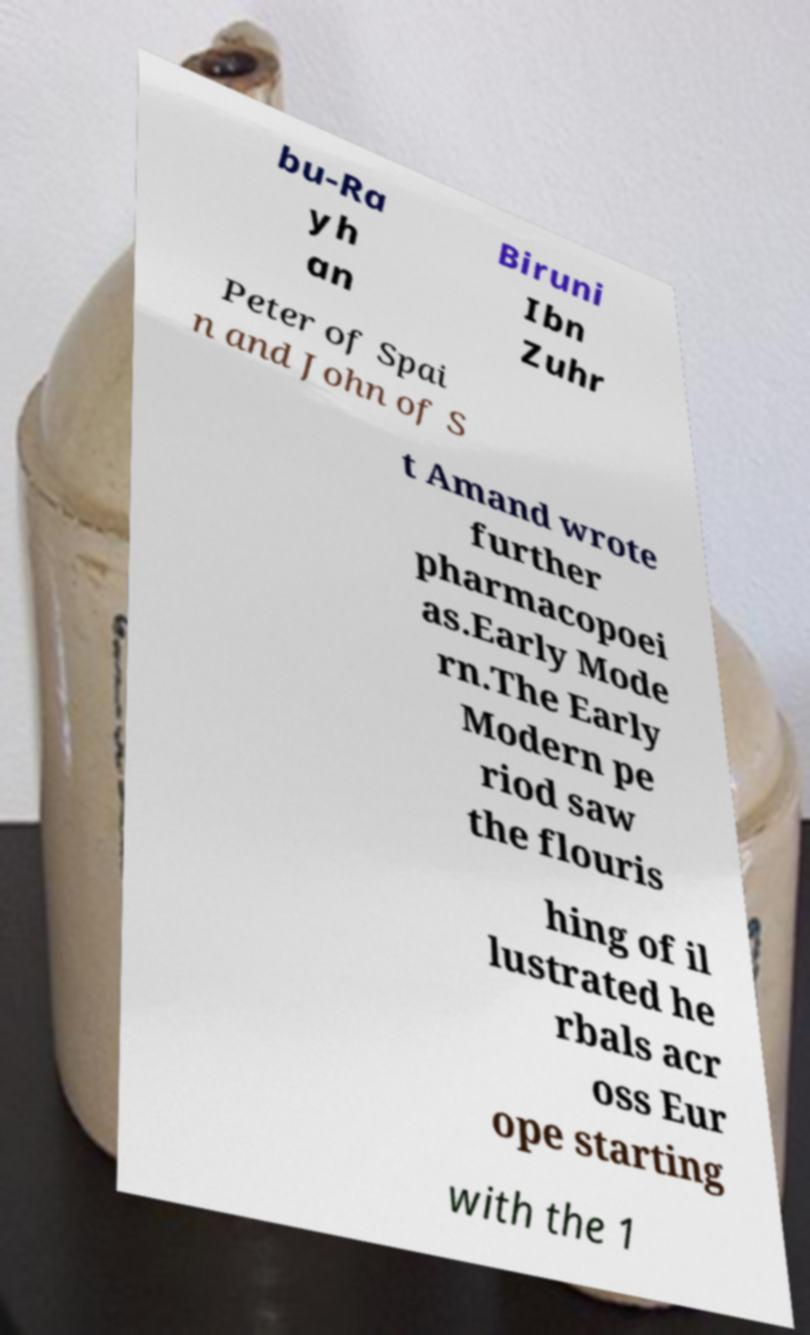Can you read and provide the text displayed in the image?This photo seems to have some interesting text. Can you extract and type it out for me? bu-Ra yh an Biruni Ibn Zuhr Peter of Spai n and John of S t Amand wrote further pharmacopoei as.Early Mode rn.The Early Modern pe riod saw the flouris hing of il lustrated he rbals acr oss Eur ope starting with the 1 